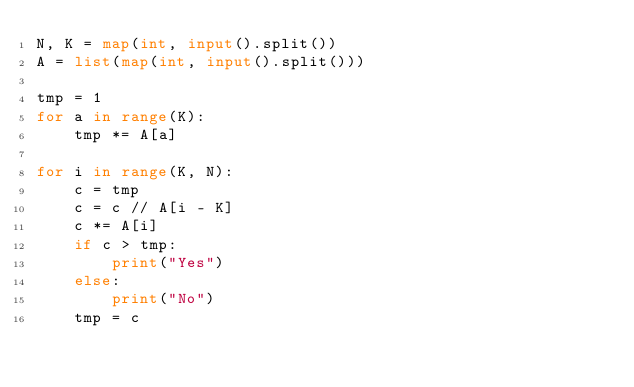Convert code to text. <code><loc_0><loc_0><loc_500><loc_500><_Python_>N, K = map(int, input().split())
A = list(map(int, input().split()))

tmp = 1
for a in range(K):
    tmp *= A[a]

for i in range(K, N):
    c = tmp
    c = c // A[i - K]
    c *= A[i]
    if c > tmp:
        print("Yes")
    else:
        print("No")
    tmp = c
</code> 